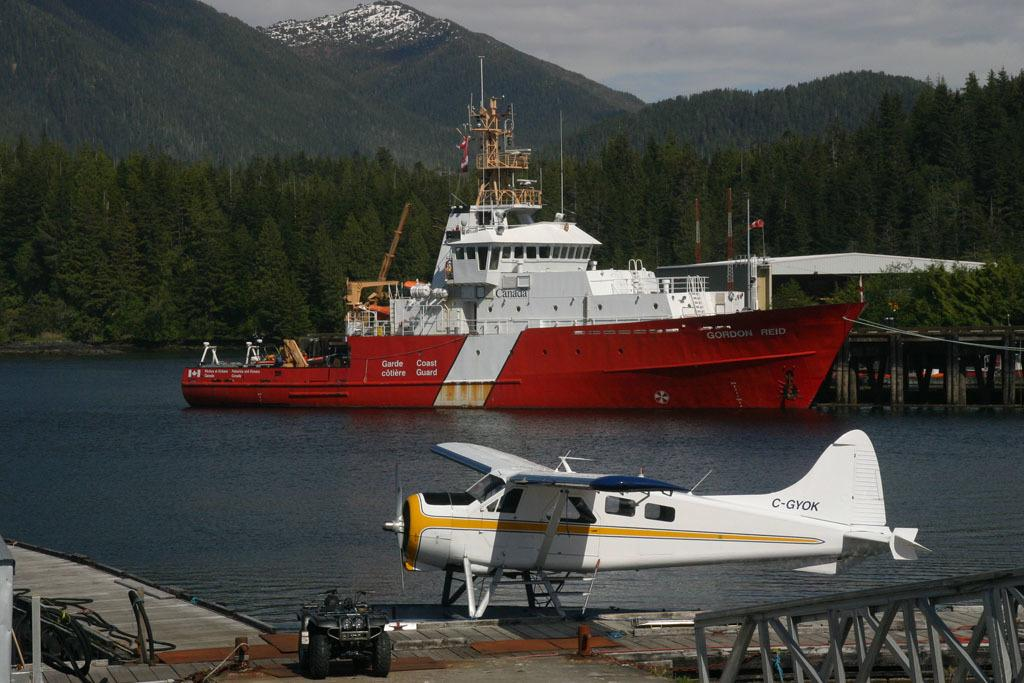What is the main subject of the image? The main subject of the image is a ship on the water. What other modes of transportation can be seen in the image? There is an airplane and a vehicle in the image. What can be seen in the background of the image? There are trees, a mountain, and the sky visible in the background of the image. What is the condition of the sky in the image? The sky is visible in the background of the image, and clouds are present. What are the sisters discussing while petting the animals in the image? There are no sisters, discussion, or pets present in the image. The image features a ship on the water, an airplane, a vehicle, trees, a mountain, and a sky with clouds. 